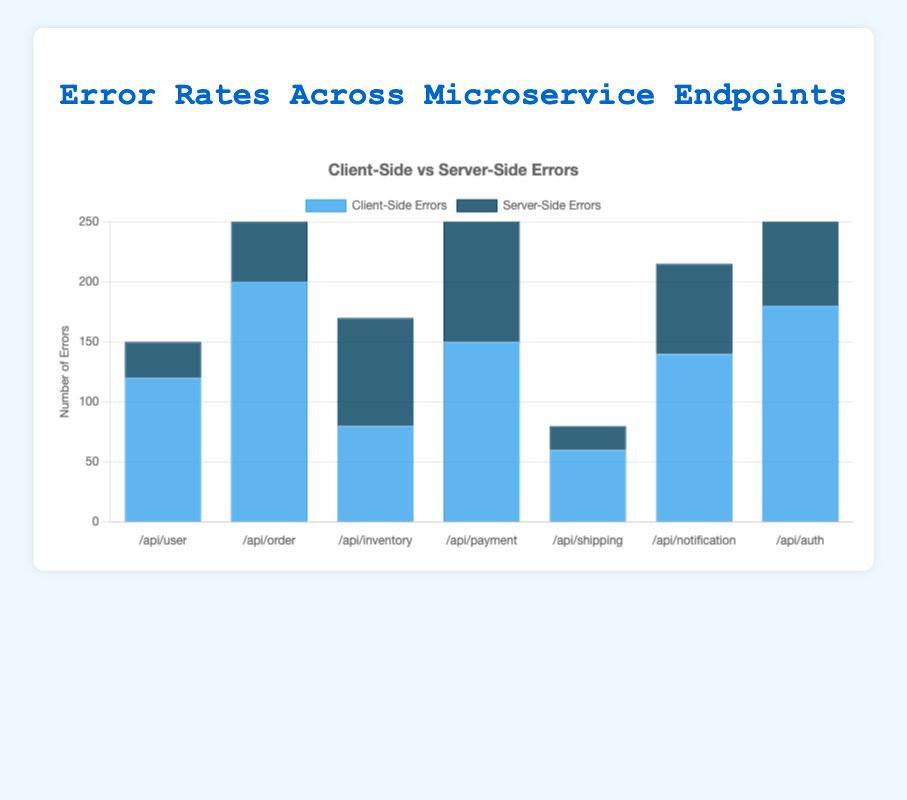Which endpoint has the highest number of client-side errors? From the bar chart, look at the height of the blue bars, which represent client-side errors. The endpoint with the highest blue bar has the most client-side errors. The endpoint "/api/order" has the highest number of client-side errors with 200.
Answer: /api/order Which endpoint has the lowest number of server-side errors? Examine the height of the dark blue bars to determine the endpoint with the smallest number of server-side errors. The endpoint "/api/shipping" has the lowest dark blue bar, indicating it has the fewest server-side errors, which is 20.
Answer: /api/shipping What is the total number of errors for the /api/payment endpoint? Sum the client-side errors and server-side errors for the /api/payment endpoint. From the chart, "/api/payment" has 150 client-side errors and 110 server-side errors. So, the total number of errors is 150 + 110 = 260.
Answer: 260 Which endpoint has a roughly equal number of client-side and server-side errors? Look for endpoints where the heights of the blue and dark blue bars are almost the same. The endpoint "/api/inventory" shows 80 client-side errors and 90 server-side errors, which are roughly equal.
Answer: /api/inventory Which endpoint has the highest combined total of client-side and server-side errors? To find the endpoint with the highest combined total, identify the endpoint where the sum of the heights of the blue and dark blue bars is the greatest. The endpoint "/api/order" has the highest combined total of errors (200 client-side + 50 server-side = 250).
Answer: /api/order Compare the number of client-side errors between the /api/user and /api/auth endpoints. Which one is greater and by how much? Identify the height of the blue bars for both endpoints. "/api/user" has 120 client-side errors and "/api/auth" has 180 client-side errors. The difference is 180 - 120 = 60. So, the /api/auth endpoint has 60 more client-side errors than /api/user.
Answer: /api/auth by 60 How many more server-side errors are there in /api/payment compared to /api/user? Look at the dark blue bars for both endpoints. "/api/payment" has 110 server-side errors and "/api/user" has 30 server-side errors. The difference is 110 - 30 = 80.
Answer: 80 What percentage of the total errors for the /api/shipping endpoint are server-side errors? First, find the total errors for /api/shipping (client-side + server-side = 60 + 20 = 80). Then, calculate the server-side error percentage: (20/80) * 100 = 25%.
Answer: 25% Between the /api/notification and /api/payment endpoints, which has a higher number of server-side errors and by how much? Examine the dark blue bars for both endpoints. "/api/notification" has 75 server-side errors and "/api/payment" has 110. The difference is 110 - 75 = 35.
Answer: /api/payment by 35 Which endpoint has a higher client-side error count, /api/order or /api/auth, and by how much? Compare the heights of the blue bars for both endpoints. "/api/order" has 200 client-side errors and "/api/auth" has 180 client-side errors. The difference is 200 - 180 = 20.
Answer: /api/order by 20 